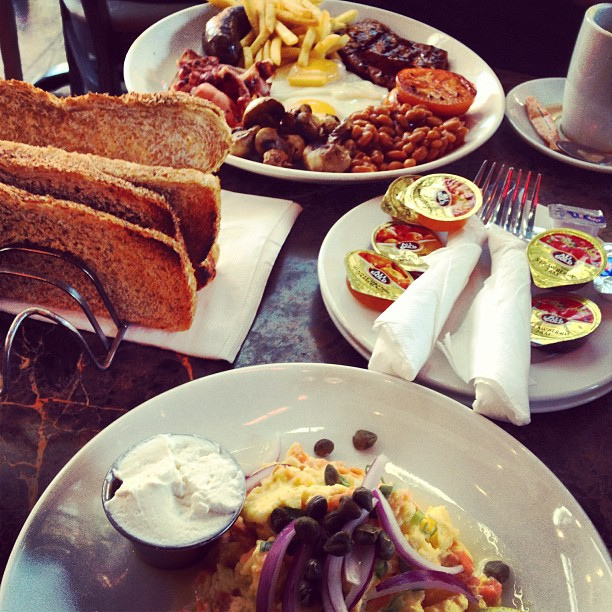What if this table setting was part of a magical breakfast organized by a wizard? What might be special or unusual about the meal? In a magical breakfast organized by a wizard, the meal would be full of enchanting surprises. The beans might glow softly, pulsing with warmth, while the sausages could sizzle with magical sparks as they are cut. The eggs could change color with each bite, giving a burst of different flavors every time. The toast would never get cold or stale, always maintaining its perfect crunch, and the coffee in the mug might refill itself continuously. Also, tiny fairies might deliver the preserves, fluttering down to the table and sprinkling a bit of enchantment dust on each plate, making the entire meal an unforgettable experience. 